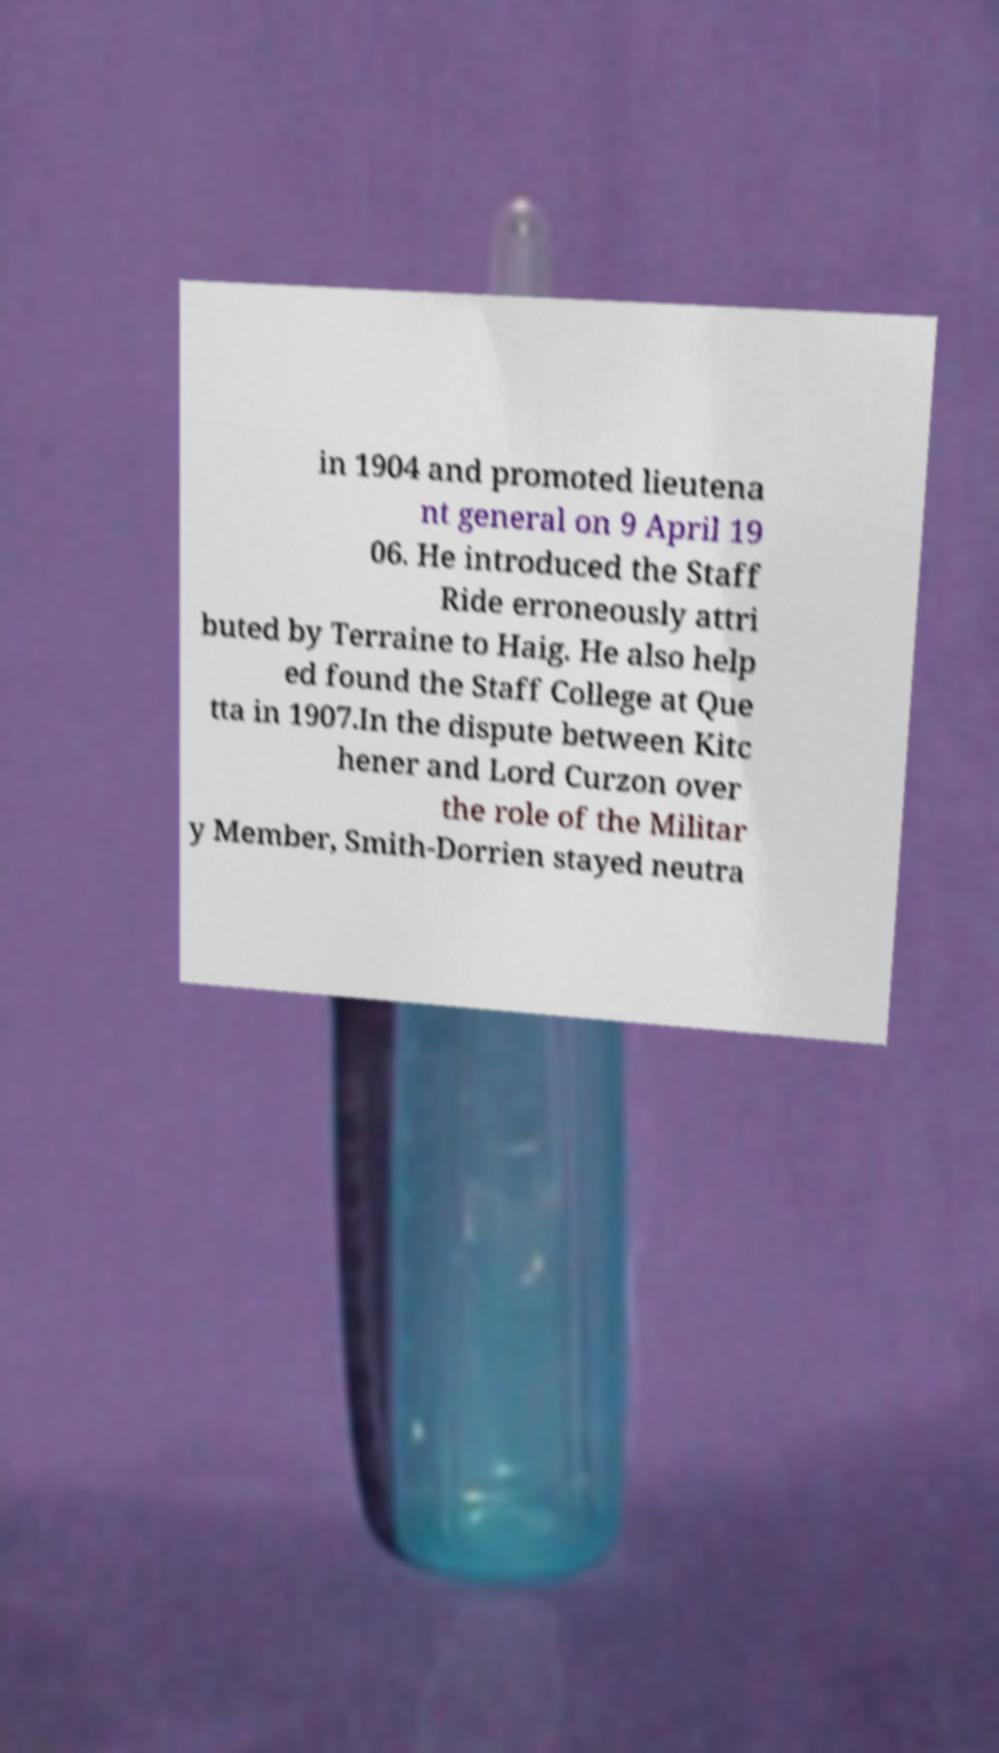For documentation purposes, I need the text within this image transcribed. Could you provide that? in 1904 and promoted lieutena nt general on 9 April 19 06. He introduced the Staff Ride erroneously attri buted by Terraine to Haig. He also help ed found the Staff College at Que tta in 1907.In the dispute between Kitc hener and Lord Curzon over the role of the Militar y Member, Smith-Dorrien stayed neutra 